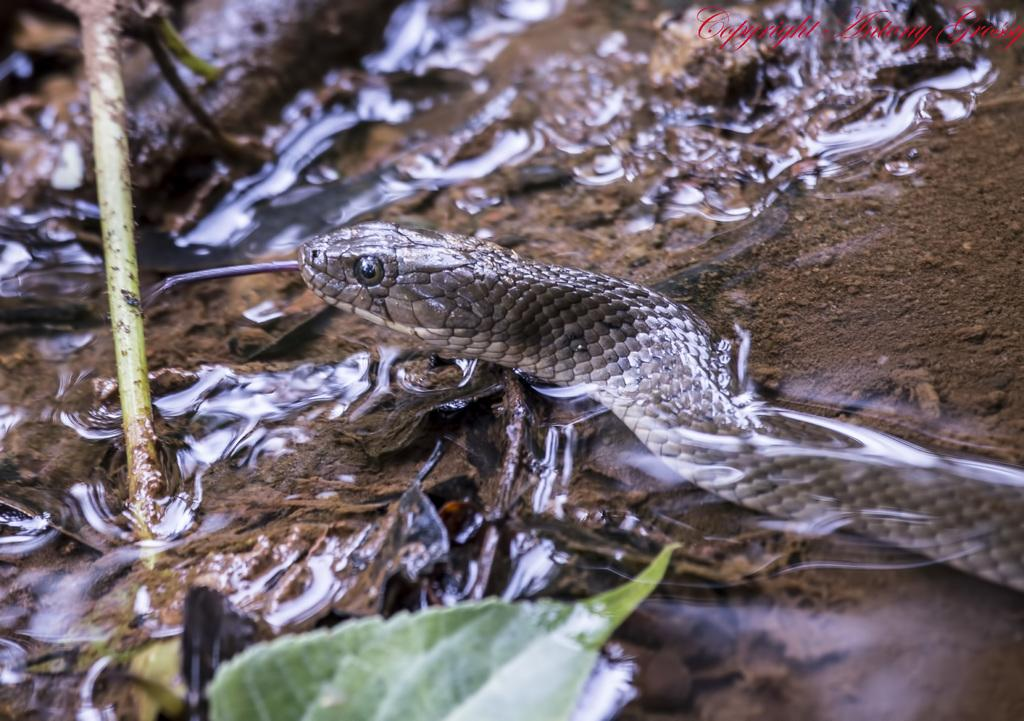What type of animal is present in the image? There is a snake in the image. What plant-related elements can be seen in the image? There is a leaf and a stem visible in the image. What natural elements are present in the image? Water and soil are visible in the image. Where is the text located in the image? The text is in the top right corner of the image. Can you touch the books in the image? There are no books present in the image, so it is not possible to touch them. 